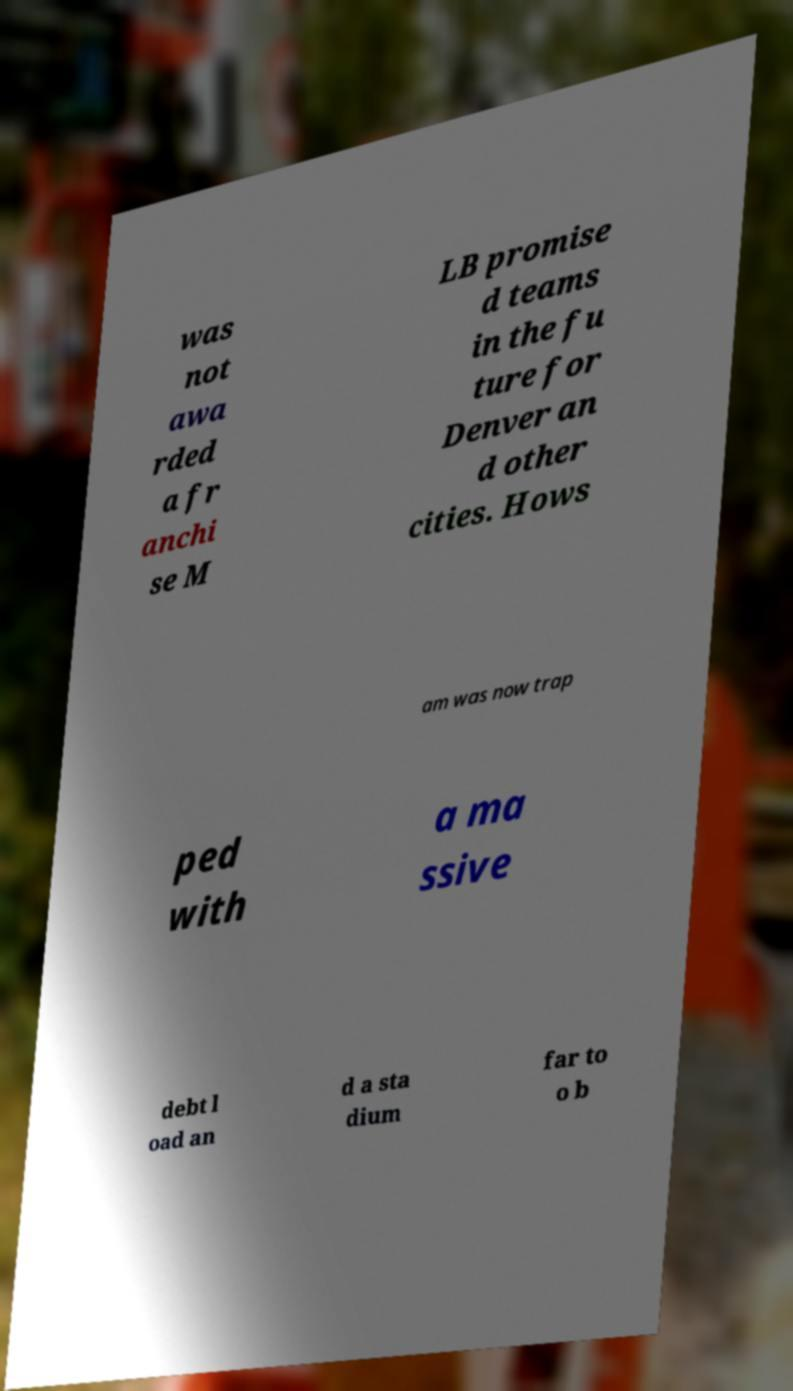Can you read and provide the text displayed in the image?This photo seems to have some interesting text. Can you extract and type it out for me? was not awa rded a fr anchi se M LB promise d teams in the fu ture for Denver an d other cities. Hows am was now trap ped with a ma ssive debt l oad an d a sta dium far to o b 